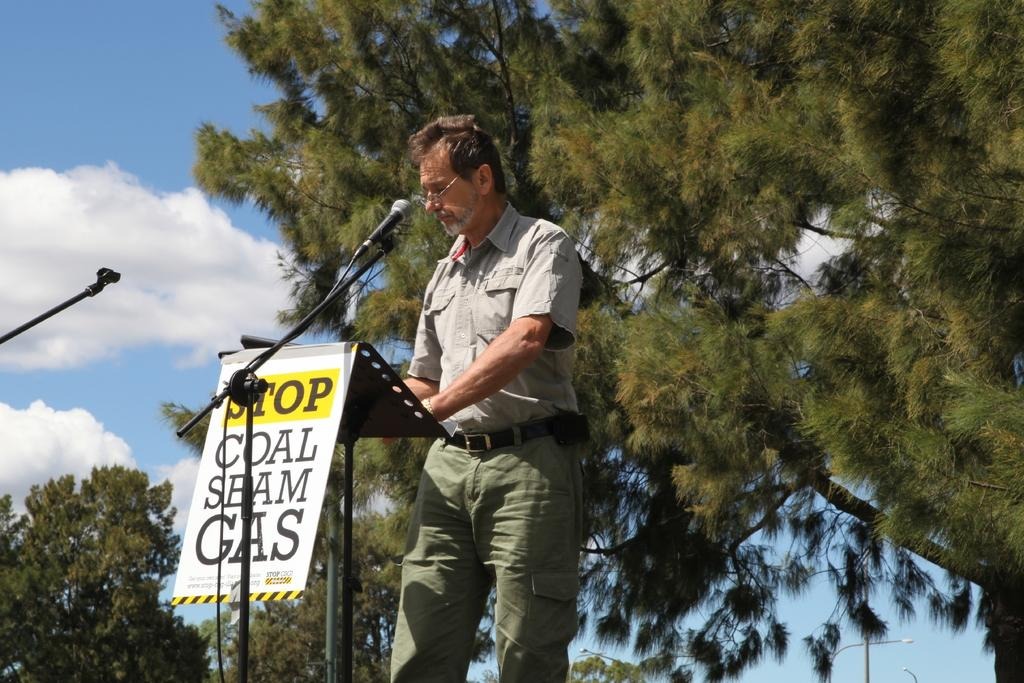Who or what is present in the image? There is a person in the image. What is the person doing in the image? The person is resting his hands on an object. What can be seen on the wall in the image? There is a poster with text in the image. What equipment is visible in the image? There are microphones in the image. What type of natural environment is visible in the image? There are trees in the image. What type of artificial lighting is present in the image? There are lights in the image. What type of vertical structures are present in the image? There are poles in the image. What is visible in the sky in the image? The sky is visible in the image, and clouds are present. How many bikes are parked next to the trees in the image? There are no bikes present in the image; only trees, lights, poles, and the sky are visible. 